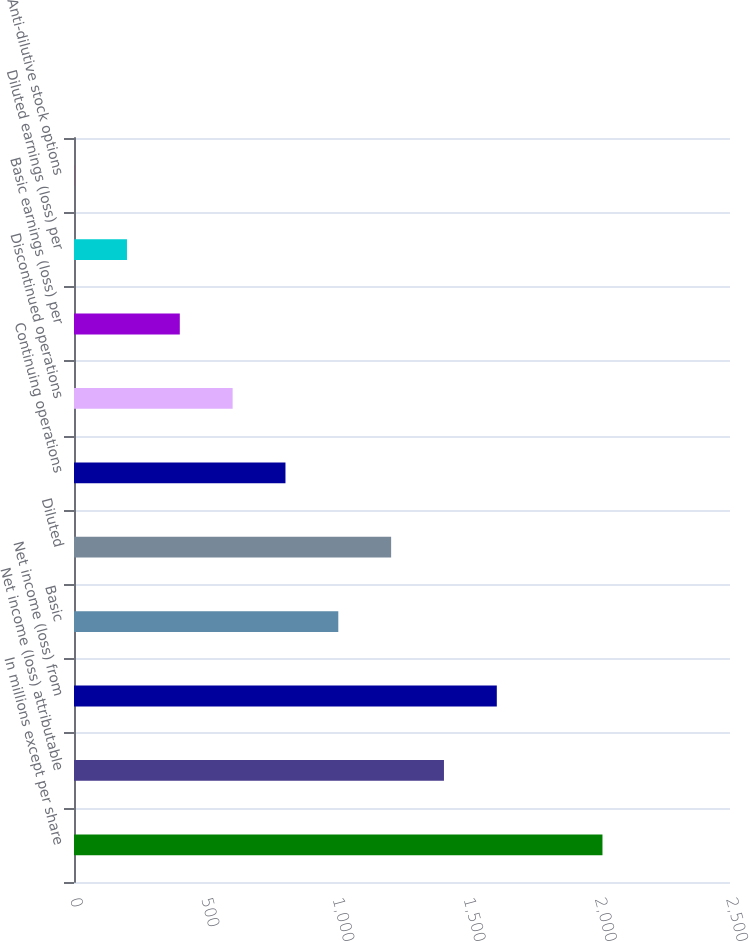<chart> <loc_0><loc_0><loc_500><loc_500><bar_chart><fcel>In millions except per share<fcel>Net income (loss) attributable<fcel>Net income (loss) from<fcel>Basic<fcel>Diluted<fcel>Continuing operations<fcel>Discontinued operations<fcel>Basic earnings (loss) per<fcel>Diluted earnings (loss) per<fcel>Anti-dilutive stock options<nl><fcel>2014<fcel>1409.95<fcel>1611.3<fcel>1007.25<fcel>1208.6<fcel>805.9<fcel>604.55<fcel>403.2<fcel>201.85<fcel>0.5<nl></chart> 